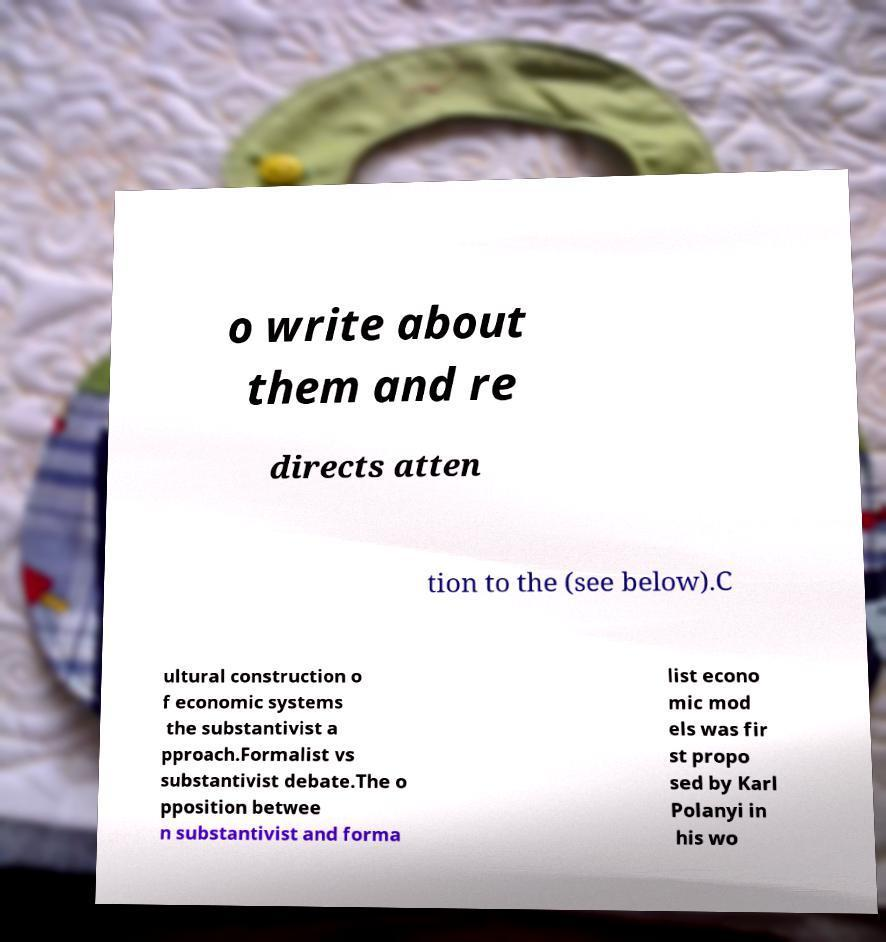Could you assist in decoding the text presented in this image and type it out clearly? o write about them and re directs atten tion to the (see below).C ultural construction o f economic systems the substantivist a pproach.Formalist vs substantivist debate.The o pposition betwee n substantivist and forma list econo mic mod els was fir st propo sed by Karl Polanyi in his wo 